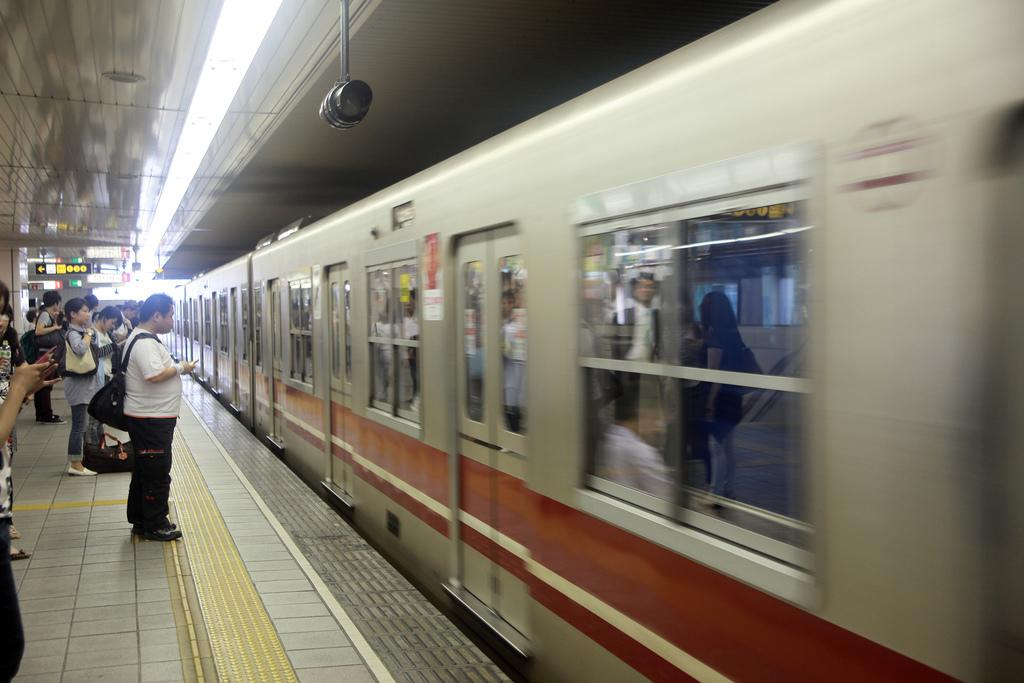What is the main subject of the image? The main subject of the image is a train. Are there any people in the image? Yes, there are people in the image. What can be seen in the background of the image? The sky is visible at the top of the image. What type of apple is being crushed by the train in the image? There is no apple present in the image, nor is there any indication of a train crushing anything. 